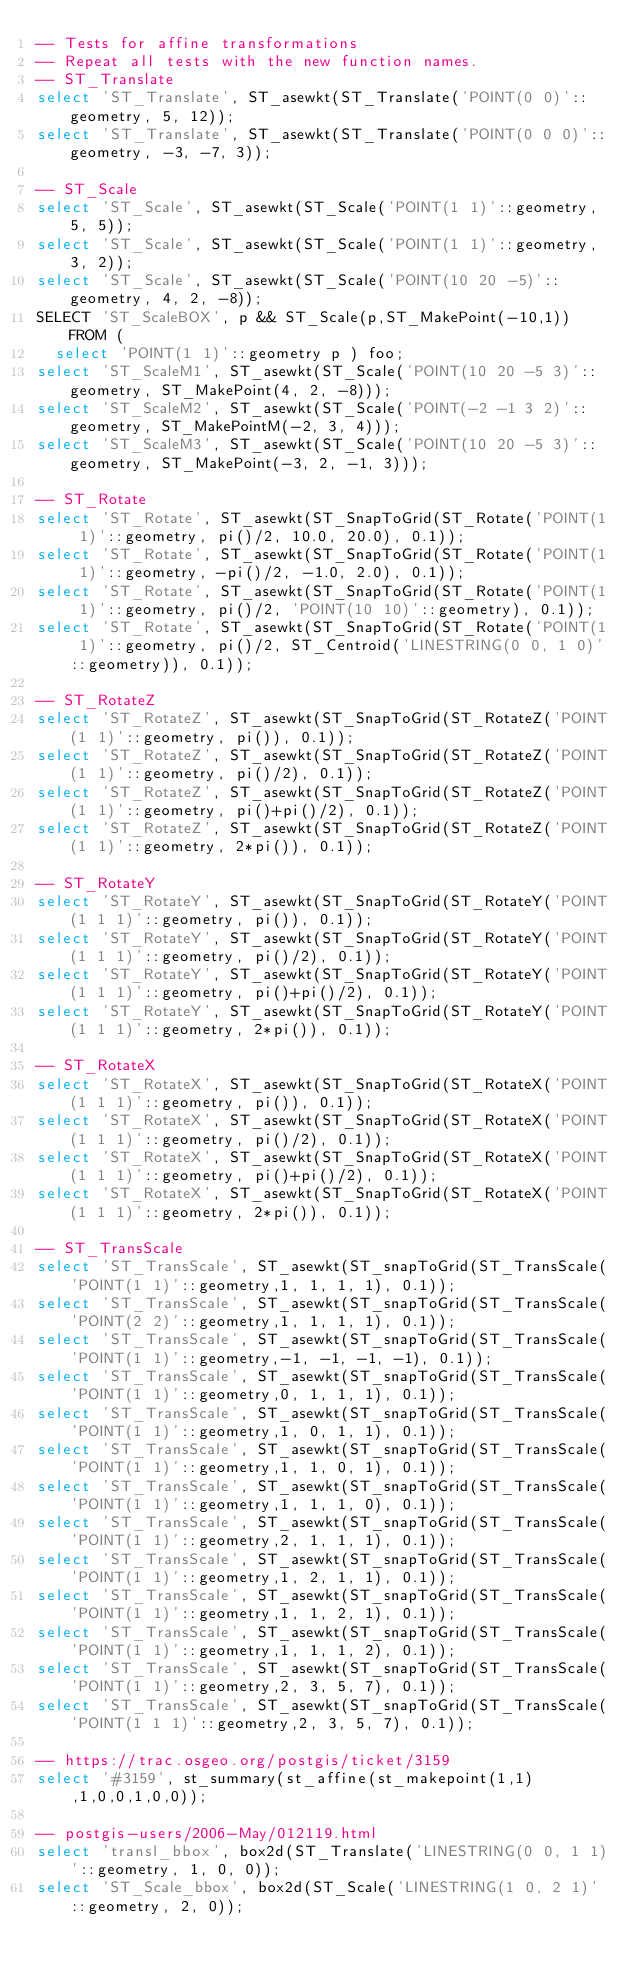Convert code to text. <code><loc_0><loc_0><loc_500><loc_500><_SQL_>-- Tests for affine transformations
-- Repeat all tests with the new function names.
-- ST_Translate
select 'ST_Translate', ST_asewkt(ST_Translate('POINT(0 0)'::geometry, 5, 12));
select 'ST_Translate', ST_asewkt(ST_Translate('POINT(0 0 0)'::geometry, -3, -7, 3));

-- ST_Scale
select 'ST_Scale', ST_asewkt(ST_Scale('POINT(1 1)'::geometry, 5, 5));
select 'ST_Scale', ST_asewkt(ST_Scale('POINT(1 1)'::geometry, 3, 2));
select 'ST_Scale', ST_asewkt(ST_Scale('POINT(10 20 -5)'::geometry, 4, 2, -8));
SELECT 'ST_ScaleBOX', p && ST_Scale(p,ST_MakePoint(-10,1)) FROM (
  select 'POINT(1 1)'::geometry p ) foo;
select 'ST_ScaleM1', ST_asewkt(ST_Scale('POINT(10 20 -5 3)'::geometry, ST_MakePoint(4, 2, -8)));
select 'ST_ScaleM2', ST_asewkt(ST_Scale('POINT(-2 -1 3 2)'::geometry, ST_MakePointM(-2, 3, 4)));
select 'ST_ScaleM3', ST_asewkt(ST_Scale('POINT(10 20 -5 3)'::geometry, ST_MakePoint(-3, 2, -1, 3)));

-- ST_Rotate
select 'ST_Rotate', ST_asewkt(ST_SnapToGrid(ST_Rotate('POINT(1 1)'::geometry, pi()/2, 10.0, 20.0), 0.1));
select 'ST_Rotate', ST_asewkt(ST_SnapToGrid(ST_Rotate('POINT(1 1)'::geometry, -pi()/2, -1.0, 2.0), 0.1));
select 'ST_Rotate', ST_asewkt(ST_SnapToGrid(ST_Rotate('POINT(1 1)'::geometry, pi()/2, 'POINT(10 10)'::geometry), 0.1));
select 'ST_Rotate', ST_asewkt(ST_SnapToGrid(ST_Rotate('POINT(1 1)'::geometry, pi()/2, ST_Centroid('LINESTRING(0 0, 1 0)'::geometry)), 0.1));

-- ST_RotateZ
select 'ST_RotateZ', ST_asewkt(ST_SnapToGrid(ST_RotateZ('POINT(1 1)'::geometry, pi()), 0.1));
select 'ST_RotateZ', ST_asewkt(ST_SnapToGrid(ST_RotateZ('POINT(1 1)'::geometry, pi()/2), 0.1));
select 'ST_RotateZ', ST_asewkt(ST_SnapToGrid(ST_RotateZ('POINT(1 1)'::geometry, pi()+pi()/2), 0.1));
select 'ST_RotateZ', ST_asewkt(ST_SnapToGrid(ST_RotateZ('POINT(1 1)'::geometry, 2*pi()), 0.1));

-- ST_RotateY
select 'ST_RotateY', ST_asewkt(ST_SnapToGrid(ST_RotateY('POINT(1 1 1)'::geometry, pi()), 0.1));
select 'ST_RotateY', ST_asewkt(ST_SnapToGrid(ST_RotateY('POINT(1 1 1)'::geometry, pi()/2), 0.1));
select 'ST_RotateY', ST_asewkt(ST_SnapToGrid(ST_RotateY('POINT(1 1 1)'::geometry, pi()+pi()/2), 0.1));
select 'ST_RotateY', ST_asewkt(ST_SnapToGrid(ST_RotateY('POINT(1 1 1)'::geometry, 2*pi()), 0.1));

-- ST_RotateX
select 'ST_RotateX', ST_asewkt(ST_SnapToGrid(ST_RotateX('POINT(1 1 1)'::geometry, pi()), 0.1));
select 'ST_RotateX', ST_asewkt(ST_SnapToGrid(ST_RotateX('POINT(1 1 1)'::geometry, pi()/2), 0.1));
select 'ST_RotateX', ST_asewkt(ST_SnapToGrid(ST_RotateX('POINT(1 1 1)'::geometry, pi()+pi()/2), 0.1));
select 'ST_RotateX', ST_asewkt(ST_SnapToGrid(ST_RotateX('POINT(1 1 1)'::geometry, 2*pi()), 0.1));

-- ST_TransScale
select 'ST_TransScale', ST_asewkt(ST_snapToGrid(ST_TransScale('POINT(1 1)'::geometry,1, 1, 1, 1), 0.1));
select 'ST_TransScale', ST_asewkt(ST_snapToGrid(ST_TransScale('POINT(2 2)'::geometry,1, 1, 1, 1), 0.1));
select 'ST_TransScale', ST_asewkt(ST_snapToGrid(ST_TransScale('POINT(1 1)'::geometry,-1, -1, -1, -1), 0.1));
select 'ST_TransScale', ST_asewkt(ST_snapToGrid(ST_TransScale('POINT(1 1)'::geometry,0, 1, 1, 1), 0.1));
select 'ST_TransScale', ST_asewkt(ST_snapToGrid(ST_TransScale('POINT(1 1)'::geometry,1, 0, 1, 1), 0.1));
select 'ST_TransScale', ST_asewkt(ST_snapToGrid(ST_TransScale('POINT(1 1)'::geometry,1, 1, 0, 1), 0.1));
select 'ST_TransScale', ST_asewkt(ST_snapToGrid(ST_TransScale('POINT(1 1)'::geometry,1, 1, 1, 0), 0.1));
select 'ST_TransScale', ST_asewkt(ST_snapToGrid(ST_TransScale('POINT(1 1)'::geometry,2, 1, 1, 1), 0.1));
select 'ST_TransScale', ST_asewkt(ST_snapToGrid(ST_TransScale('POINT(1 1)'::geometry,1, 2, 1, 1), 0.1));
select 'ST_TransScale', ST_asewkt(ST_snapToGrid(ST_TransScale('POINT(1 1)'::geometry,1, 1, 2, 1), 0.1));
select 'ST_TransScale', ST_asewkt(ST_snapToGrid(ST_TransScale('POINT(1 1)'::geometry,1, 1, 1, 2), 0.1));
select 'ST_TransScale', ST_asewkt(ST_snapToGrid(ST_TransScale('POINT(1 1)'::geometry,2, 3, 5, 7), 0.1));
select 'ST_TransScale', ST_asewkt(ST_snapToGrid(ST_TransScale('POINT(1 1 1)'::geometry,2, 3, 5, 7), 0.1));

-- https://trac.osgeo.org/postgis/ticket/3159
select '#3159', st_summary(st_affine(st_makepoint(1,1),1,0,0,1,0,0));

-- postgis-users/2006-May/012119.html
select 'transl_bbox', box2d(ST_Translate('LINESTRING(0 0, 1 1)'::geometry, 1, 0, 0));
select 'ST_Scale_bbox', box2d(ST_Scale('LINESTRING(1 0, 2 1)'::geometry, 2, 0));</code> 